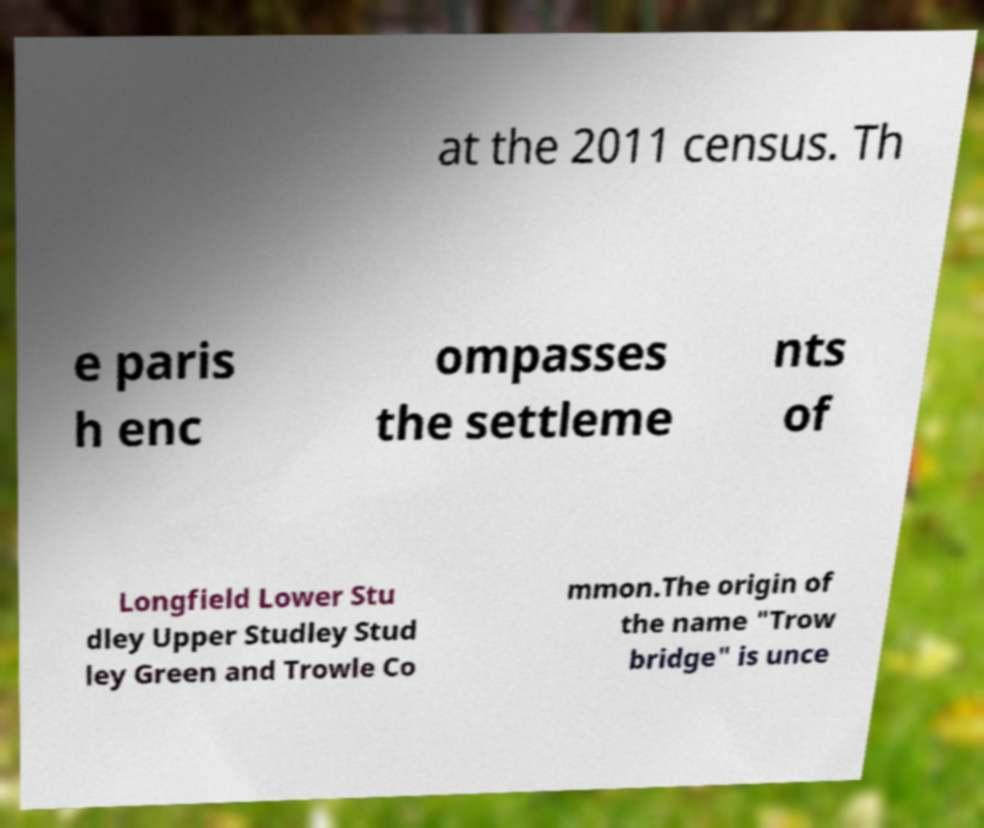There's text embedded in this image that I need extracted. Can you transcribe it verbatim? at the 2011 census. Th e paris h enc ompasses the settleme nts of Longfield Lower Stu dley Upper Studley Stud ley Green and Trowle Co mmon.The origin of the name "Trow bridge" is unce 